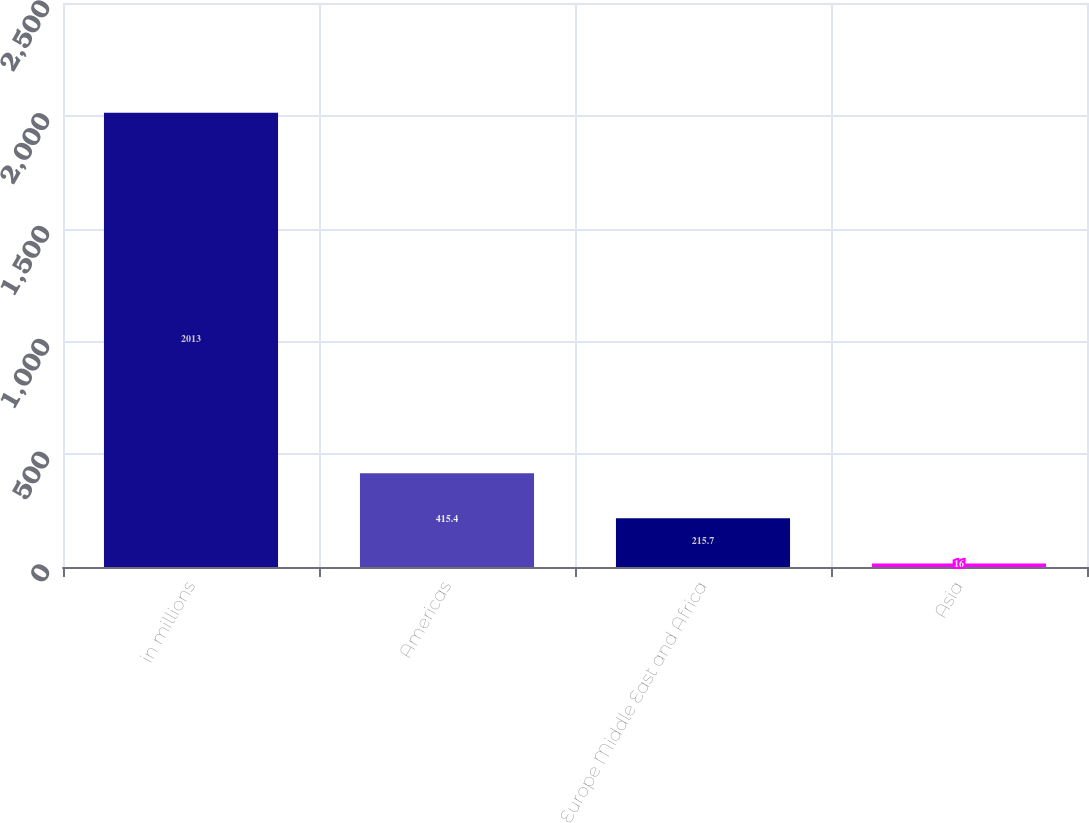Convert chart to OTSL. <chart><loc_0><loc_0><loc_500><loc_500><bar_chart><fcel>in millions<fcel>Americas<fcel>Europe Middle East and Africa<fcel>Asia<nl><fcel>2013<fcel>415.4<fcel>215.7<fcel>16<nl></chart> 